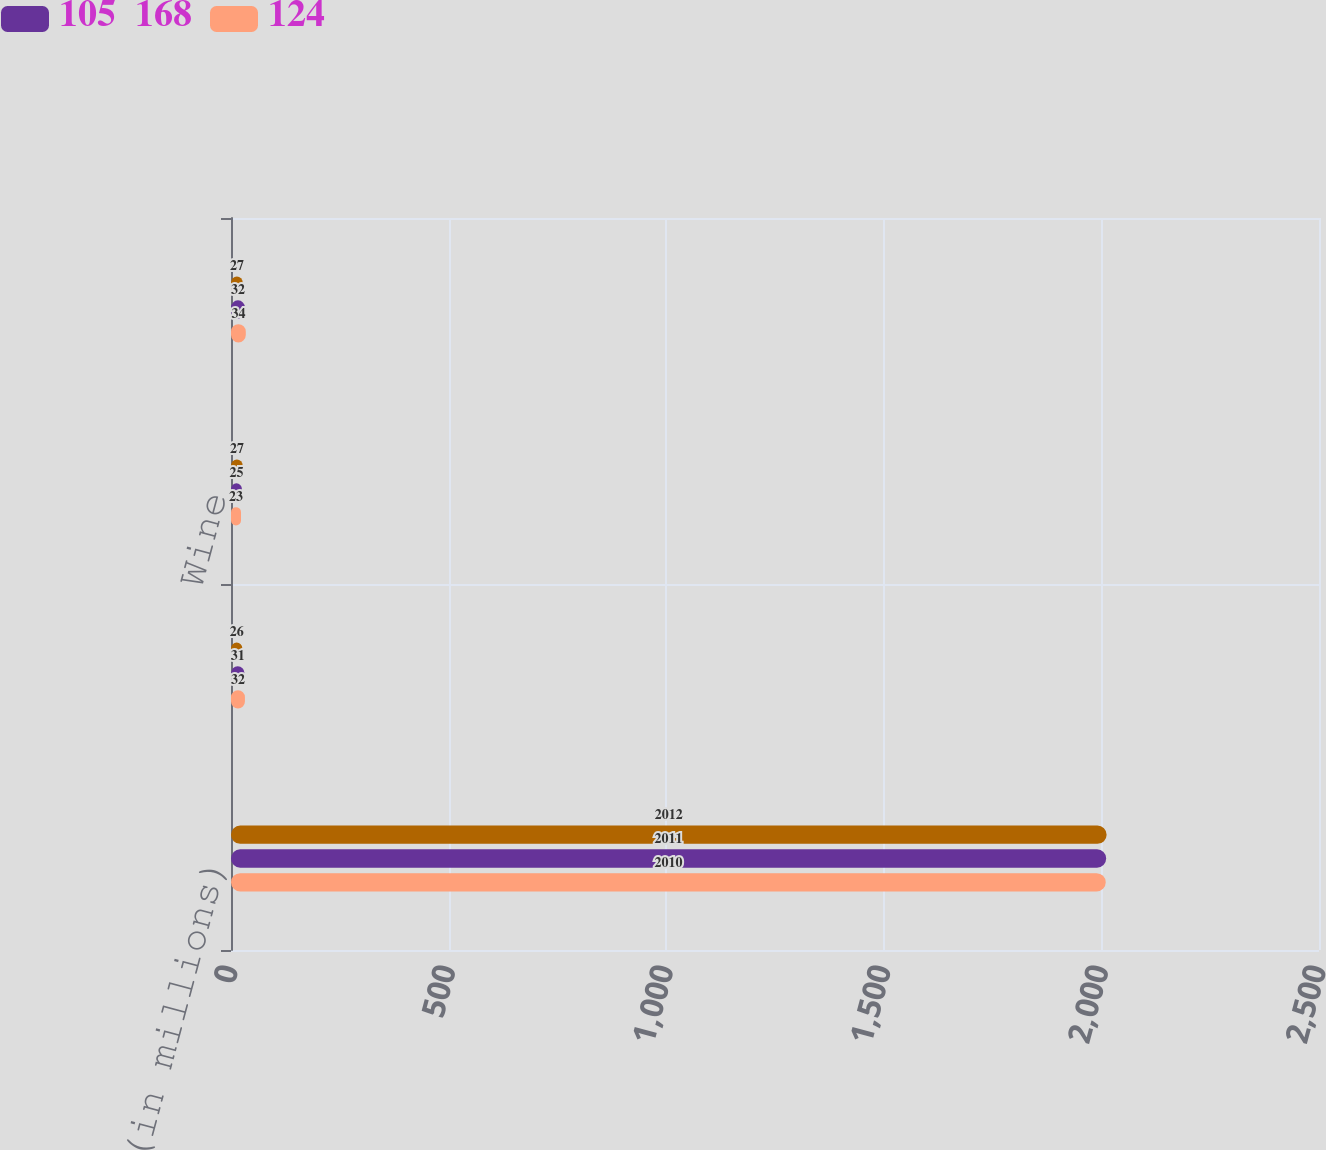Convert chart to OTSL. <chart><loc_0><loc_0><loc_500><loc_500><stacked_bar_chart><ecel><fcel>(in millions)<fcel>Smokeless products<fcel>Wine<fcel>Corporate<nl><fcel>nan<fcel>2012<fcel>26<fcel>27<fcel>27<nl><fcel>105  168<fcel>2011<fcel>31<fcel>25<fcel>32<nl><fcel>124<fcel>2010<fcel>32<fcel>23<fcel>34<nl></chart> 